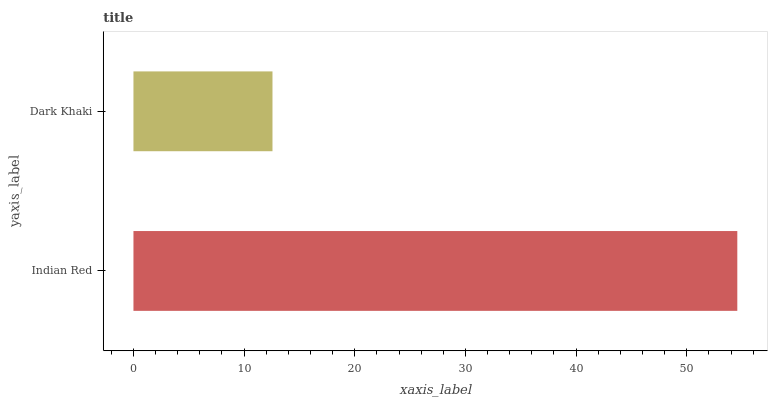Is Dark Khaki the minimum?
Answer yes or no. Yes. Is Indian Red the maximum?
Answer yes or no. Yes. Is Dark Khaki the maximum?
Answer yes or no. No. Is Indian Red greater than Dark Khaki?
Answer yes or no. Yes. Is Dark Khaki less than Indian Red?
Answer yes or no. Yes. Is Dark Khaki greater than Indian Red?
Answer yes or no. No. Is Indian Red less than Dark Khaki?
Answer yes or no. No. Is Indian Red the high median?
Answer yes or no. Yes. Is Dark Khaki the low median?
Answer yes or no. Yes. Is Dark Khaki the high median?
Answer yes or no. No. Is Indian Red the low median?
Answer yes or no. No. 